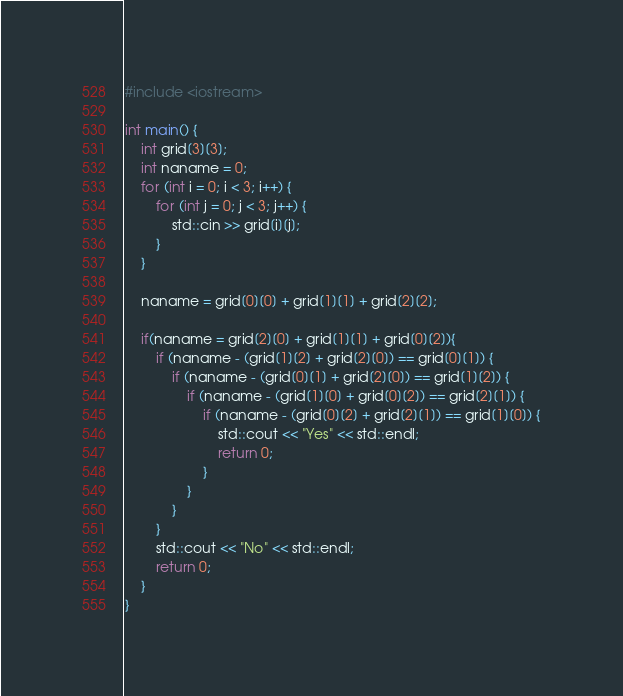Convert code to text. <code><loc_0><loc_0><loc_500><loc_500><_C++_>#include <iostream>

int main() {
	int grid[3][3];
	int naname = 0;
	for (int i = 0; i < 3; i++) {
		for (int j = 0; j < 3; j++) {
			std::cin >> grid[i][j];
		}
	}

	naname = grid[0][0] + grid[1][1] + grid[2][2];

	if(naname = grid[2][0] + grid[1][1] + grid[0][2]){
		if (naname - (grid[1][2] + grid[2][0]) == grid[0][1]) {
			if (naname - (grid[0][1] + grid[2][0]) == grid[1][2]) {
				if (naname - (grid[1][0] + grid[0][2]) == grid[2][1]) {
					if (naname - (grid[0][2] + grid[2][1]) == grid[1][0]) {
						std::cout << "Yes" << std::endl;
						return 0;
					}
				}
			}
		}
		std::cout << "No" << std::endl;
		return 0;
	}
}</code> 